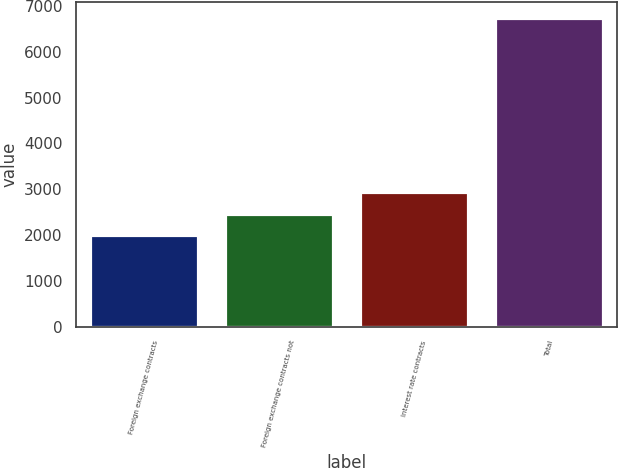Convert chart. <chart><loc_0><loc_0><loc_500><loc_500><bar_chart><fcel>Foreign exchange contracts<fcel>Foreign exchange contracts not<fcel>Interest rate contracts<fcel>Total<nl><fcel>1990<fcel>2464.9<fcel>2939.8<fcel>6739<nl></chart> 